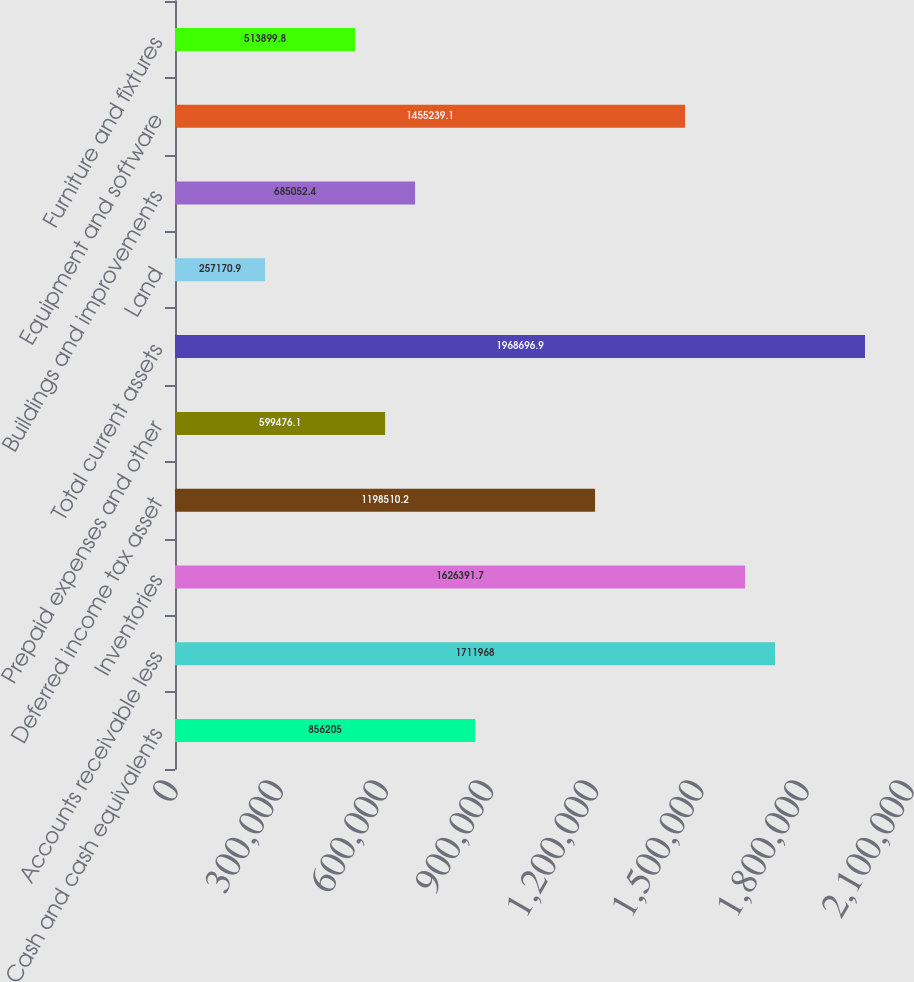<chart> <loc_0><loc_0><loc_500><loc_500><bar_chart><fcel>Cash and cash equivalents<fcel>Accounts receivable less<fcel>Inventories<fcel>Deferred income tax asset<fcel>Prepaid expenses and other<fcel>Total current assets<fcel>Land<fcel>Buildings and improvements<fcel>Equipment and software<fcel>Furniture and fixtures<nl><fcel>856205<fcel>1.71197e+06<fcel>1.62639e+06<fcel>1.19851e+06<fcel>599476<fcel>1.9687e+06<fcel>257171<fcel>685052<fcel>1.45524e+06<fcel>513900<nl></chart> 